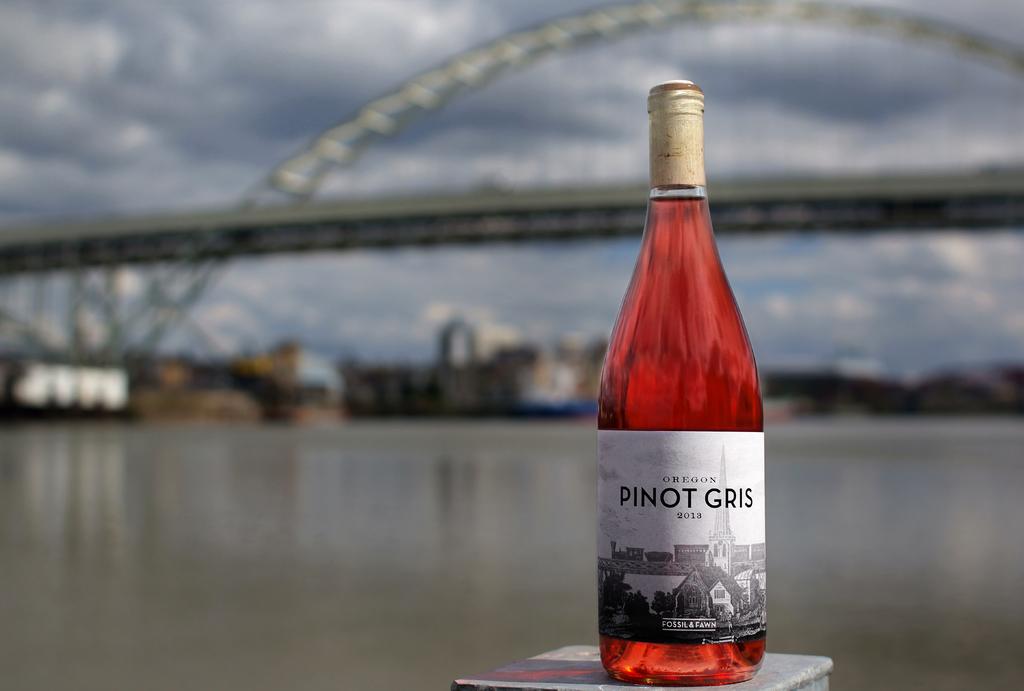What type of wine is this?
Offer a very short reply. Pinot gris. Where does the wine come from?
Keep it short and to the point. Oregon. 